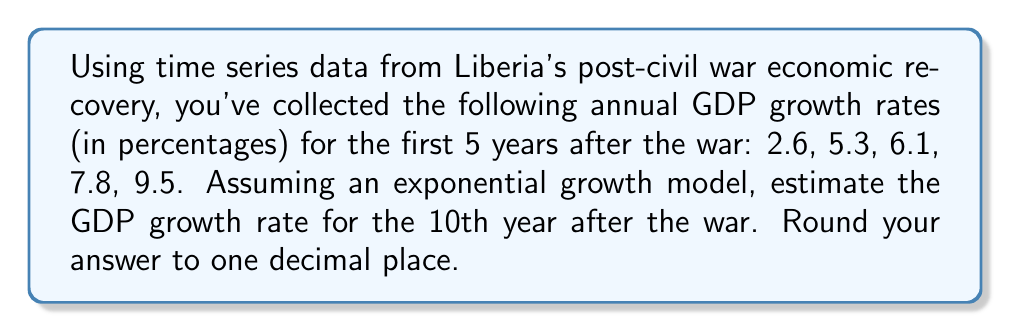Can you solve this math problem? To solve this problem, we'll use exponential regression to fit the data and then extrapolate to the 10th year. Let's follow these steps:

1) Let $y$ be the GDP growth rate and $t$ be the year (with $t=1$ for the first year).

2) The exponential model is of the form $y = ae^{bt}$, where $a$ and $b$ are constants we need to determine.

3) To linearize this model, we take the natural logarithm of both sides:
   $\ln(y) = \ln(a) + bt$

4) Let $Y = \ln(y)$ and $A = \ln(a)$. Now we have a linear equation: $Y = A + bt$

5) We can use linear regression to find $A$ and $b$. First, let's prepare our data:

   $t$ | $y$ | $Y = \ln(y)$
   1 | 2.6 | 0.9555
   2 | 5.3 | 1.6677
   3 | 6.1 | 1.8083
   4 | 7.8 | 2.0541
   5 | 9.5 | 2.2513

6) Using the linear regression formulas:
   $b = \frac{n\sum(tY) - \sum t \sum Y}{n\sum t^2 - (\sum t)^2}$
   $A = \bar{Y} - b\bar{t}$

   Where $n = 5$, $\sum t = 15$, $\sum Y = 8.7369$, $\sum(tY) = 32.5777$, $\sum t^2 = 55$

7) Calculating:
   $b = \frac{5(32.5777) - 15(8.7369)}{5(55) - 15^2} = 0.3245$
   $A = \frac{8.7369}{5} - 0.3245(\frac{15}{5}) = 0.7849$

8) So our linearized model is: $Y = 0.7849 + 0.3245t$

9) Converting back to the exponential form:
   $y = e^{0.7849} \cdot e^{0.3245t} = 2.1922 \cdot e^{0.3245t}$

10) To estimate the GDP growth rate for the 10th year, we plug in $t = 10$:
    $y = 2.1922 \cdot e^{0.3245(10)} = 2.1922 \cdot e^{3.245} = 54.8803$

11) Rounding to one decimal place: 54.9%
Answer: 54.9% 